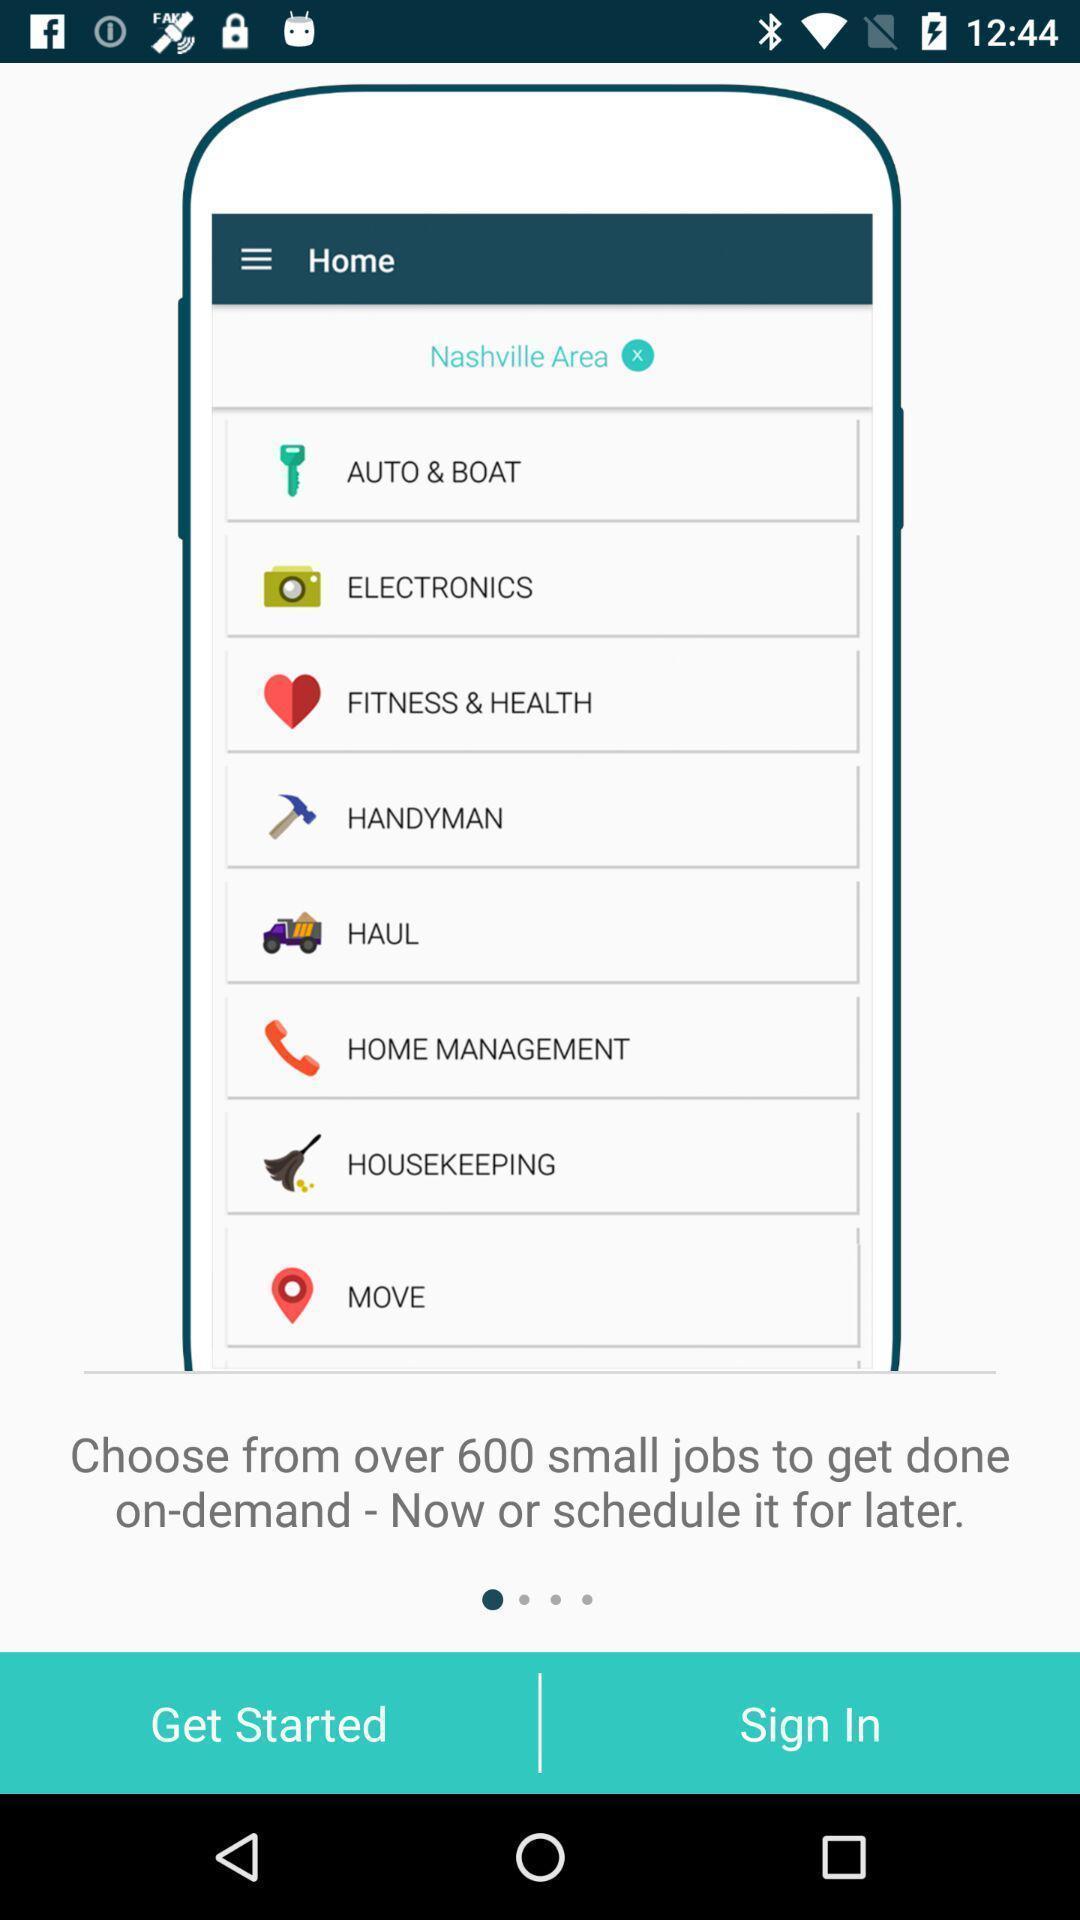Give me a summary of this screen capture. Starting page. 